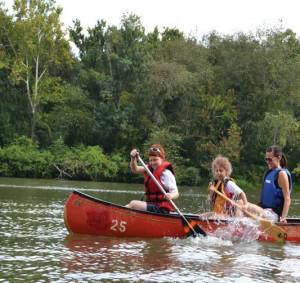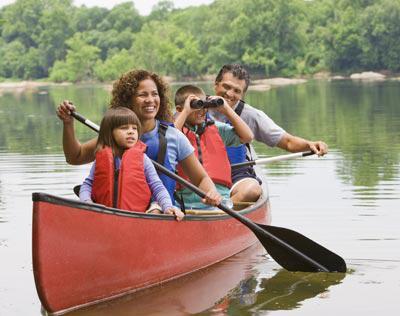The first image is the image on the left, the second image is the image on the right. Considering the images on both sides, is "In the red boat in the left image, there are three people." valid? Answer yes or no. Yes. The first image is the image on the left, the second image is the image on the right. Examine the images to the left and right. Is the description "The left image shows three people in a lefward-facing horizontal red-orange canoe." accurate? Answer yes or no. Yes. 